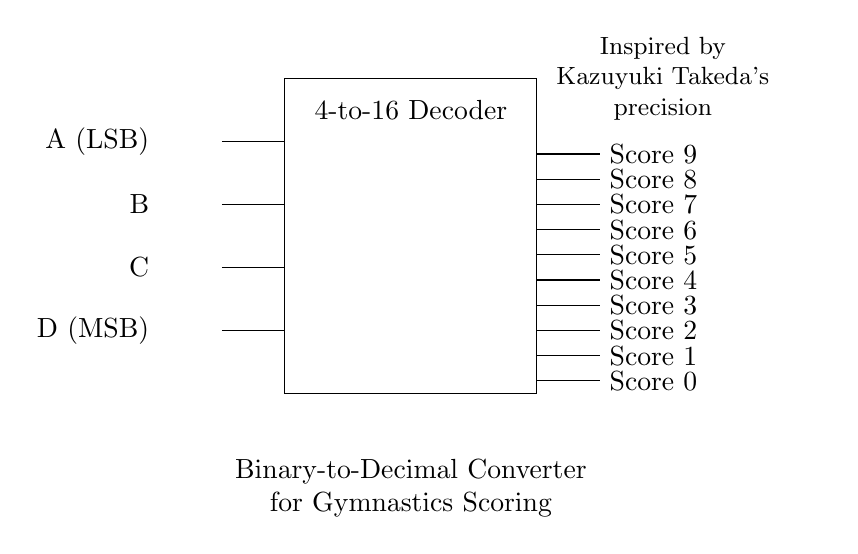What is the type of circuit shown? The circuit is a binary-to-decimal converter circuit. This is determined from the explanatory text in the circuit diagram, which describes its function.
Answer: binary-to-decimal converter How many input lines are there? There are four input lines labeled A, B, C, and D. This can be seen from the left side of the circuit where these inputs are depicted.
Answer: four What does the 'LSB' stand for in this circuit? 'LSB' stands for Least Significant Bit. It is indicated next to input A, showing that it is the input with the lowest value in the binary representation.
Answer: Least Significant Bit Which component is responsible for converting the binary input? The component responsible is the 4-to-16 Decoder. This is directly shown in the rectangle labeled as such in the circuit diagram.
Answer: 4-to-16 Decoder How many output scores can the circuit display? The circuit can display ten output scores, ranging from 0 to 9. This is indicated by the output wires labeled "Score 0" to "Score 9".
Answer: ten What inspired this circuit's design? The circuit's design is inspired by Kazuyuki Takeda's precision, as noted in the reference text in the top right corner of the diagram.
Answer: Kazuyuki Takeda's precision What is the highest score output this circuit can show? The highest score output that this circuit can show is nine. This can be concluded from the outputs labeled from "Score 0" to "Score 9".
Answer: nine 